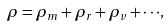Convert formula to latex. <formula><loc_0><loc_0><loc_500><loc_500>\rho = \rho _ { m } + \rho _ { r } + \rho _ { v } + \cdot \cdot \cdot ,</formula> 